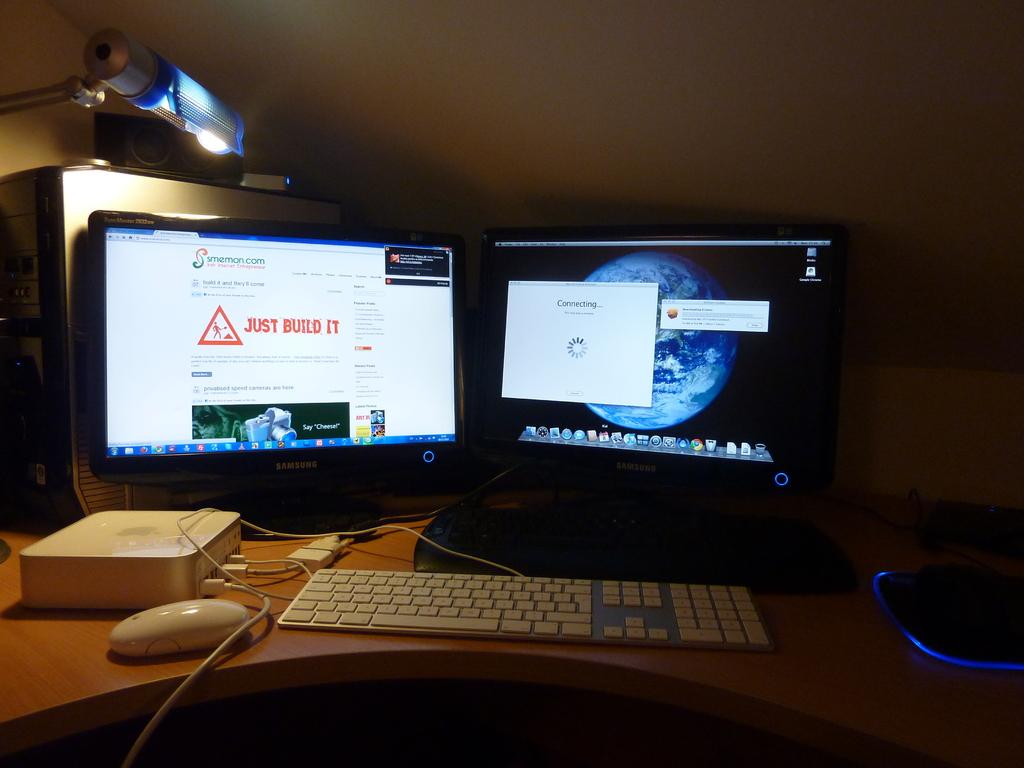<image>
Summarize the visual content of the image. Two computer screens are shown on a desk, the one on the right is trying to connect. 